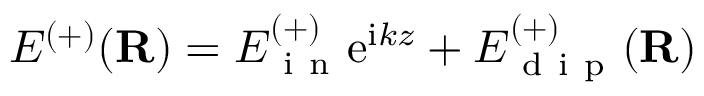Convert formula to latex. <formula><loc_0><loc_0><loc_500><loc_500>E ^ { ( + ) } ( \mathbf R ) = E _ { i n } ^ { ( + ) } e ^ { i k z } + E _ { d i p } ^ { ( + ) } ( \mathbf R )</formula> 